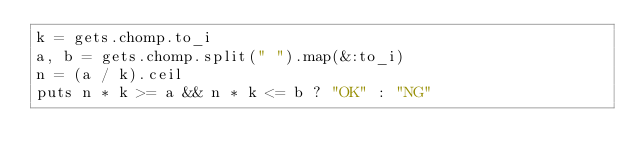<code> <loc_0><loc_0><loc_500><loc_500><_Ruby_>k = gets.chomp.to_i
a, b = gets.chomp.split(" ").map(&:to_i)
n = (a / k).ceil
puts n * k >= a && n * k <= b ? "OK" : "NG"

</code> 